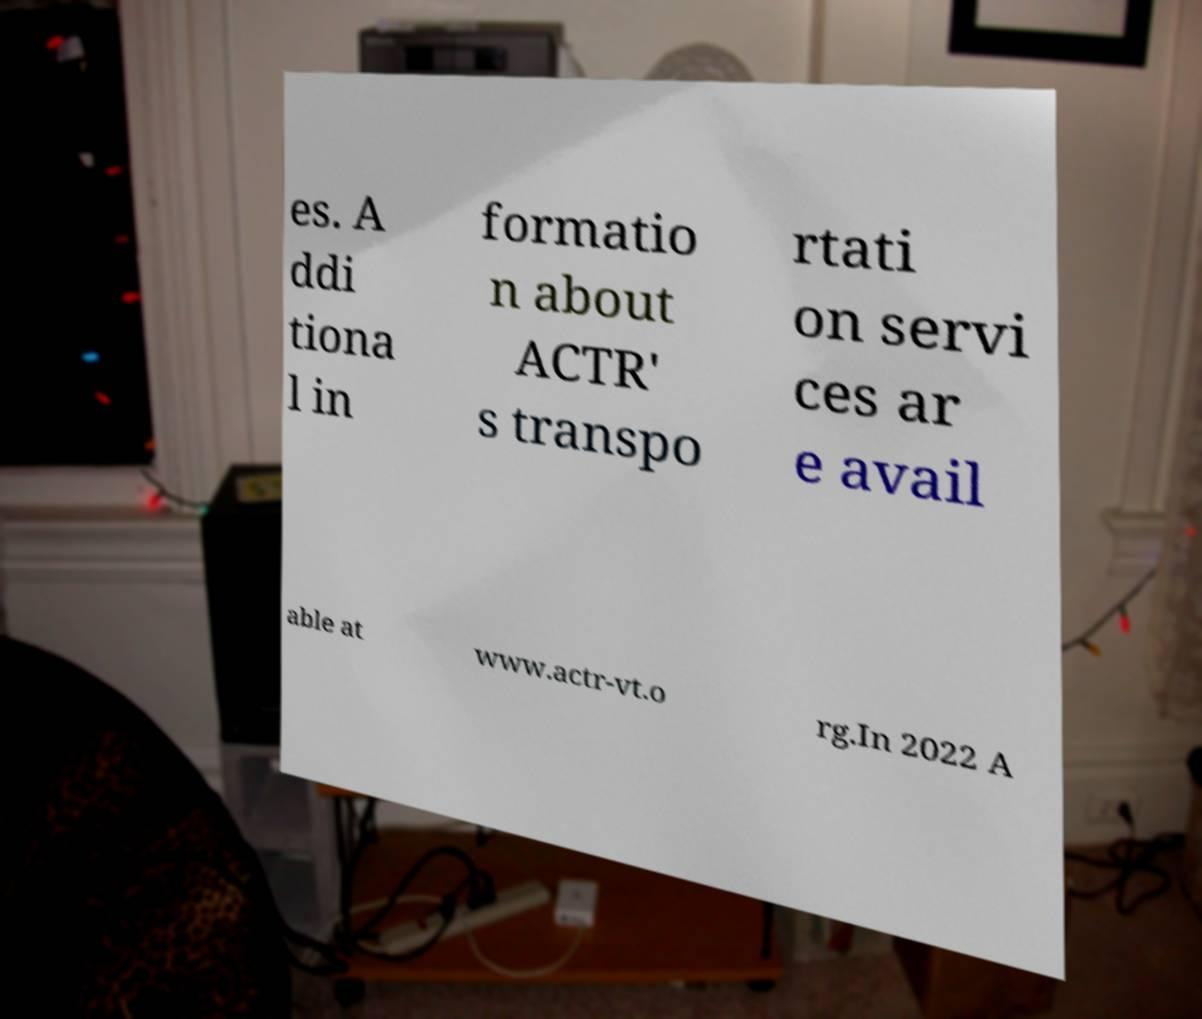Please read and relay the text visible in this image. What does it say? es. A ddi tiona l in formatio n about ACTR' s transpo rtati on servi ces ar e avail able at www.actr-vt.o rg.In 2022 A 